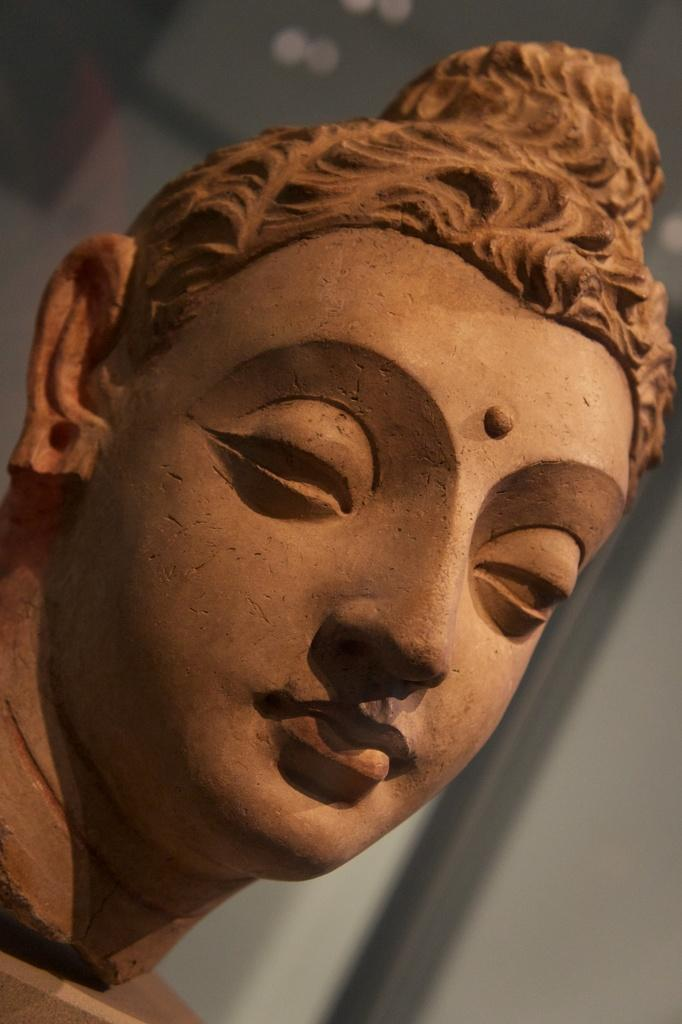What is the main subject of the image? There is a statue of a woman's face in the image. Where is the statue located? The statue is placed on a table. What can be seen in the background of the image? There is a door and a wall visible in the background of the image. What is the judge's ruling in the battle depicted in the image? There is no judge, battle, or any related elements present in the image. The image only features a statue of a woman's face placed on a table, with a door and a wall visible in the background. 